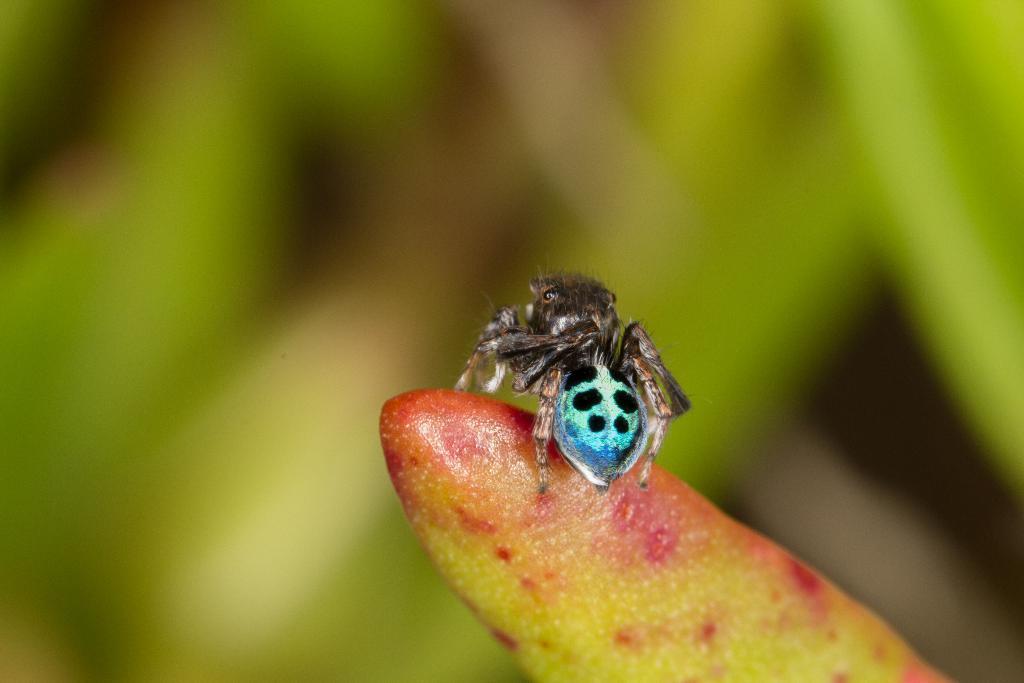Can you describe this image briefly? In this image, I can see an insect on a flower bus. The background looks green in color, which is blurred. 